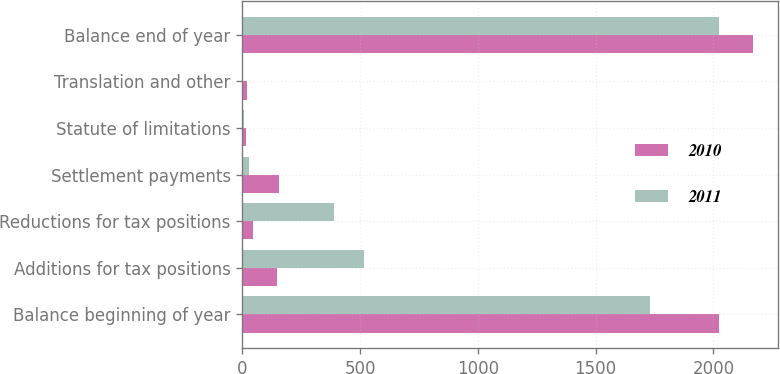Convert chart. <chart><loc_0><loc_0><loc_500><loc_500><stacked_bar_chart><ecel><fcel>Balance beginning of year<fcel>Additions for tax positions<fcel>Reductions for tax positions<fcel>Settlement payments<fcel>Statute of limitations<fcel>Translation and other<fcel>Balance end of year<nl><fcel>2010<fcel>2022<fcel>147<fcel>46<fcel>156<fcel>15<fcel>18<fcel>2167<nl><fcel>2011<fcel>1731<fcel>517<fcel>391<fcel>30<fcel>7<fcel>2<fcel>2022<nl></chart> 